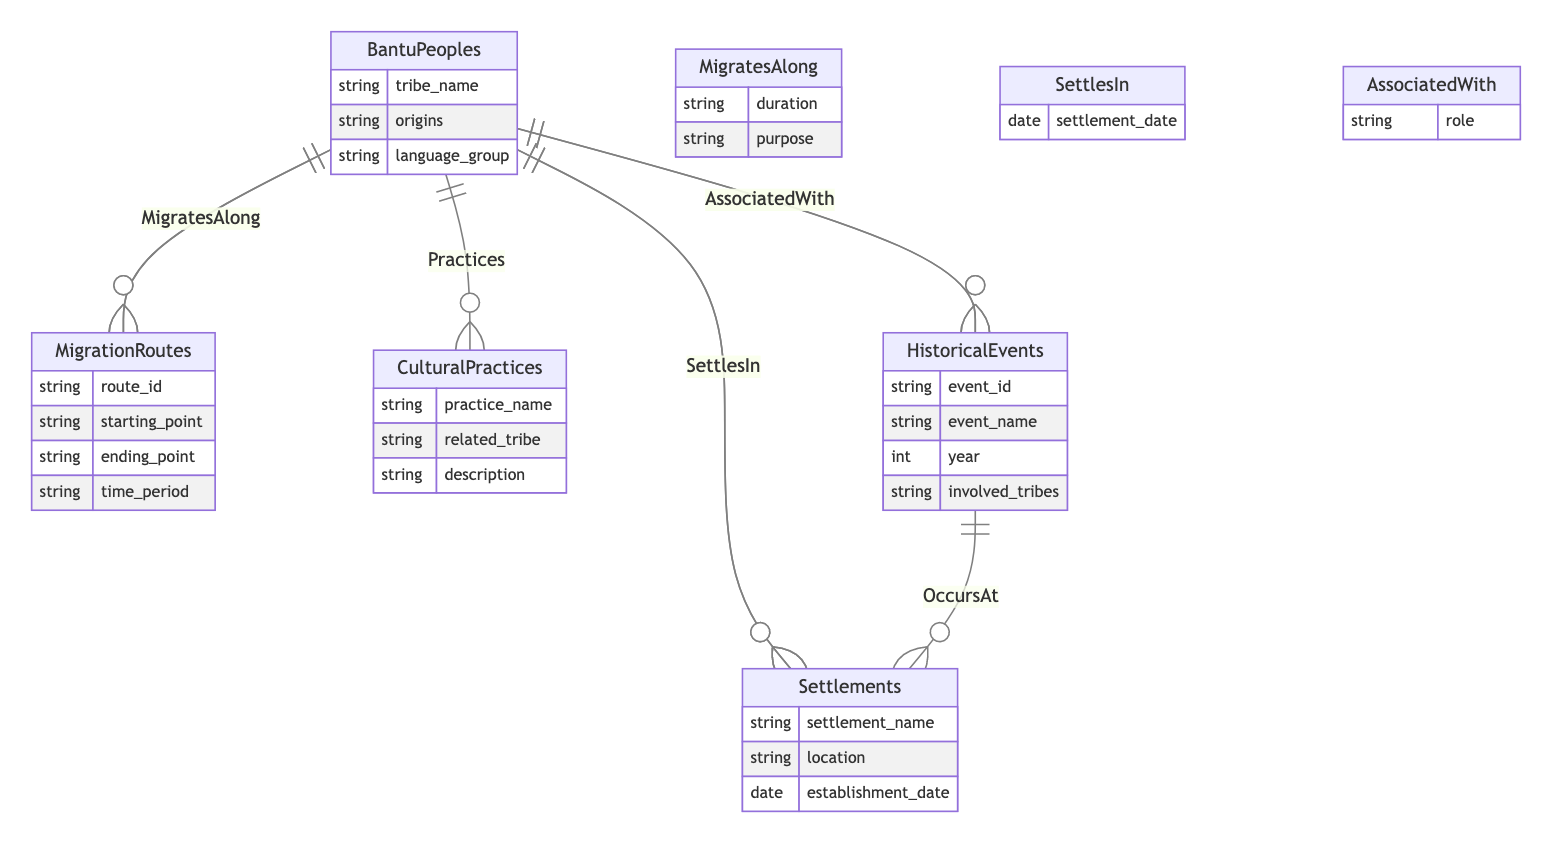What's the name of one entity in the diagram? The diagram includes several entities, among which one is "BantuPeoples."
Answer: BantuPeoples How many relationships are shown in the diagram? The diagram lists five relationships between the entities, namely "MigratesAlong," "SettlesIn," "Practices," "AssociatedWith," and "OccursAt."
Answer: 5 What is the purpose of the "SettlesIn" relationship? The "SettlesIn" relationship connects "BantuPeoples" to "Settlements" and has an attribute "settlement_date," indicating when a tribe settled in a particular location.
Answer: settlement_date Which entity is directly associated with cultural practices? The "CulturalPractices" entity is directly associated with "BantuPeoples" through the "Practices" relationship, indicating the cultural activities that the tribes engage in.
Answer: CulturalPractices What is the role attribute in the "AssociatedWith" relationship? The "AssociatedWith" relationship links "BantuPeoples" and "HistoricalEvents" with an attribute "role," which describes the involvement of a tribe in a specific historical event.
Answer: role Which entity has a location attribute? The "Settlements" entity contains an attribute called "location," which provides the geographical details of various settlements established by the Bantu peoples.
Answer: location What connects "HistoricalEvents" and "Settlements"? The relationship "OccursAt" connects "HistoricalEvents" and "Settlements," indicating where historical events took place.
Answer: OccursAt Can you name an attribute of the "MigrationRoutes" entity? The "MigrationRoutes" entity contains attributes such as "route_id," "starting_point," "ending_point," and "time_period," which provide details about migratory paths.
Answer: route_id What is the main focus of the entities in this diagram? The main focus of the entities in the diagram revolves around the historical migration patterns of the Bantu peoples, including their routes, settlements, and cultural practices.
Answer: Historical migration patterns of Bantu peoples 